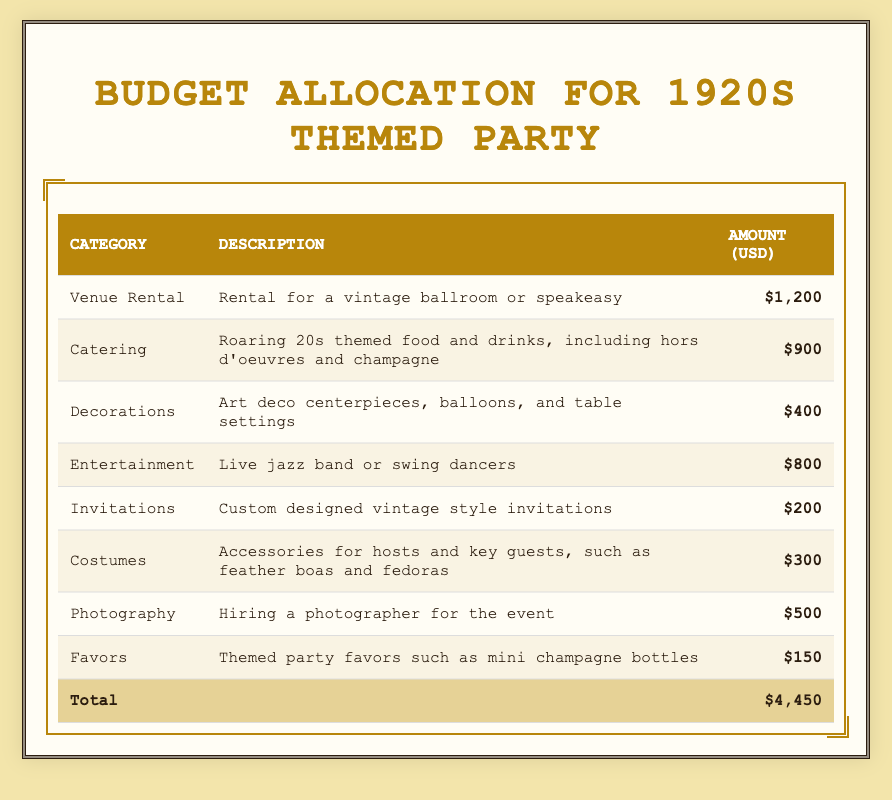What is the total budget allocation for the party? To find the total budget allocation, you sum the amounts from all categories: 1200 + 900 + 400 + 800 + 200 + 300 + 500 + 150 = 4450.
Answer: 4450 Which category has the highest budget allocation? By examining the amounts, Venue Rental has the highest allocation at 1200.
Answer: Venue Rental How much is allocated for decorations and favors combined? To find the combined total for Decorations and Favors, you add their amounts: 400 + 150 = 550.
Answer: 550 Is the amount spent on catering more than the amount spent on photography? Catering is allocated 900 and Photography is 500. Since 900 is greater than 500, the statement is true.
Answer: Yes What percentage of the total budget is allocated to entertainment? The amount for Entertainment is 800. To find the percentage, divide 800 by the total budget (4450) and multiply by 100: (800/4450) * 100 = approximately 17.98%.
Answer: Approximately 17.98% How much less is allocated for costumes compared to venue rental? The amount for Venue Rental is 1200 and for Costumes is 300. Subtract the two amounts: 1200 - 300 = 900.
Answer: 900 Which category has the lowest budget allocation, and how much is it? The lowest allocation is for Favors, which is 150.
Answer: Favors; 150 If the budget for invitations were doubled, what would the new total budget be? The original budget for Invitations is 200. If doubled, it becomes 400. Then, add this new amount to the total budget: 4450 - 200 + 400 = 4650.
Answer: 4650 How much do the combined costs of catering and entertainment exceed the cost of photography? Add the costs for Catering (900) and Entertainment (800): 900 + 800 = 1700. Then subtract the cost of Photography (500): 1700 - 500 = 1200.
Answer: 1200 